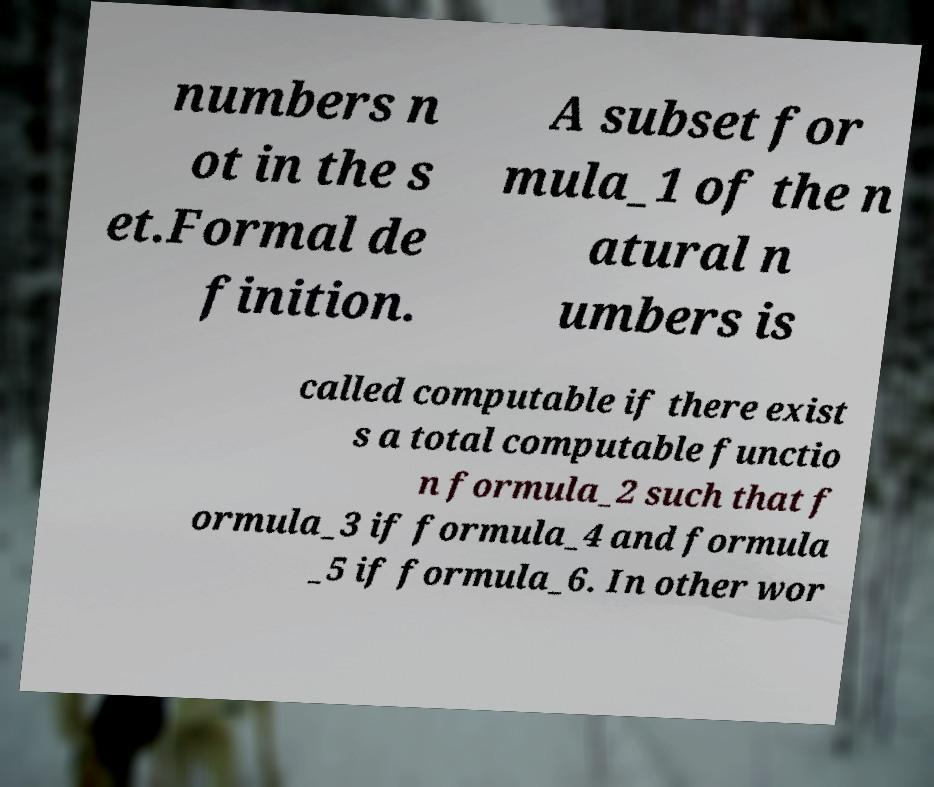Can you accurately transcribe the text from the provided image for me? numbers n ot in the s et.Formal de finition. A subset for mula_1 of the n atural n umbers is called computable if there exist s a total computable functio n formula_2 such that f ormula_3 if formula_4 and formula _5 if formula_6. In other wor 